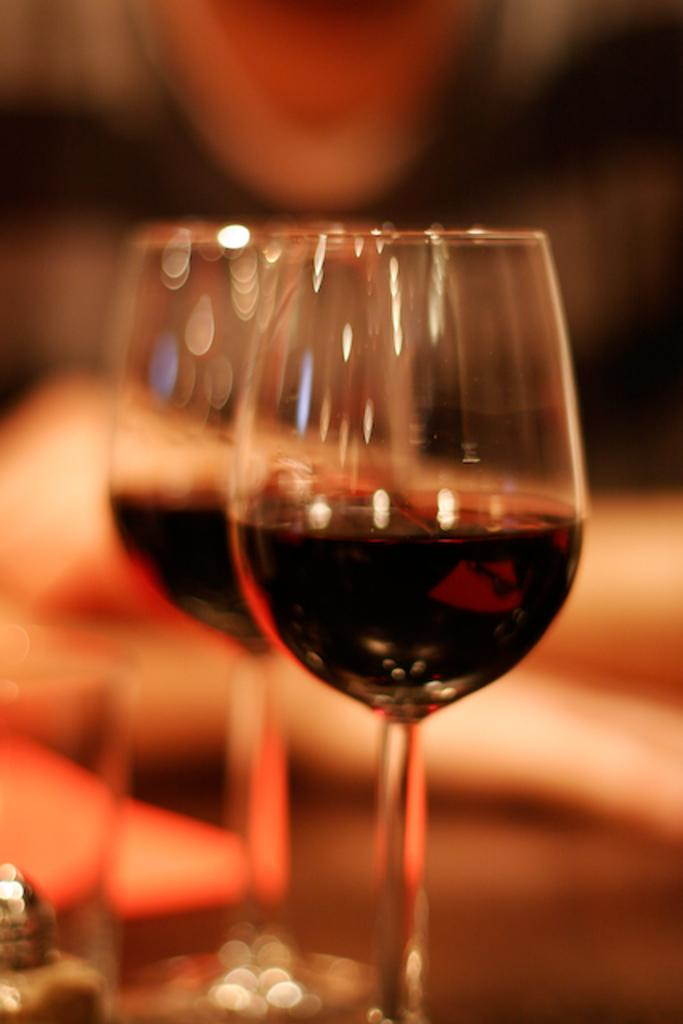What is in the glasses that are visible in the image? There are glasses with a drink in the image. What else can be seen on the table besides the glasses? There are objects on the table. Can you describe the person behind the table? There is a person behind the table, but their appearance or actions are not specified in the provided facts. What type of parent is depicted in the image? There is no parent depicted in the image; it features glasses with a drink, objects on a table, and a person behind the table. What is the destination of the voyage shown in the image? There is no voyage depicted in the image; it features glasses with a drink, objects on a table, and a person behind the table. 